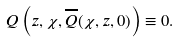Convert formula to latex. <formula><loc_0><loc_0><loc_500><loc_500>Q \left ( z , \chi , \overline { Q } ( \chi , z , 0 ) \right ) \equiv 0 .</formula> 